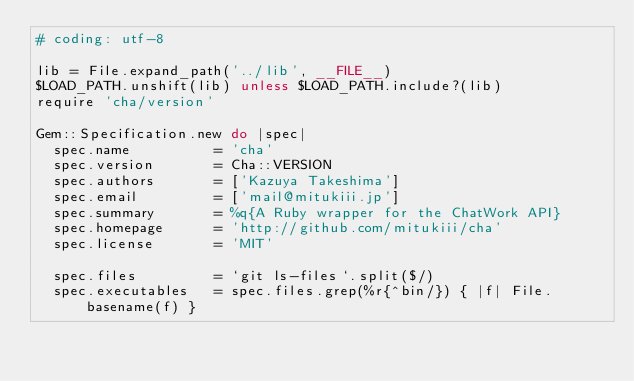<code> <loc_0><loc_0><loc_500><loc_500><_Ruby_># coding: utf-8

lib = File.expand_path('../lib', __FILE__)
$LOAD_PATH.unshift(lib) unless $LOAD_PATH.include?(lib)
require 'cha/version'

Gem::Specification.new do |spec|
  spec.name          = 'cha'
  spec.version       = Cha::VERSION
  spec.authors       = ['Kazuya Takeshima']
  spec.email         = ['mail@mitukiii.jp']
  spec.summary       = %q{A Ruby wrapper for the ChatWork API}
  spec.homepage      = 'http://github.com/mitukiii/cha'
  spec.license       = 'MIT'

  spec.files         = `git ls-files`.split($/)
  spec.executables   = spec.files.grep(%r{^bin/}) { |f| File.basename(f) }</code> 